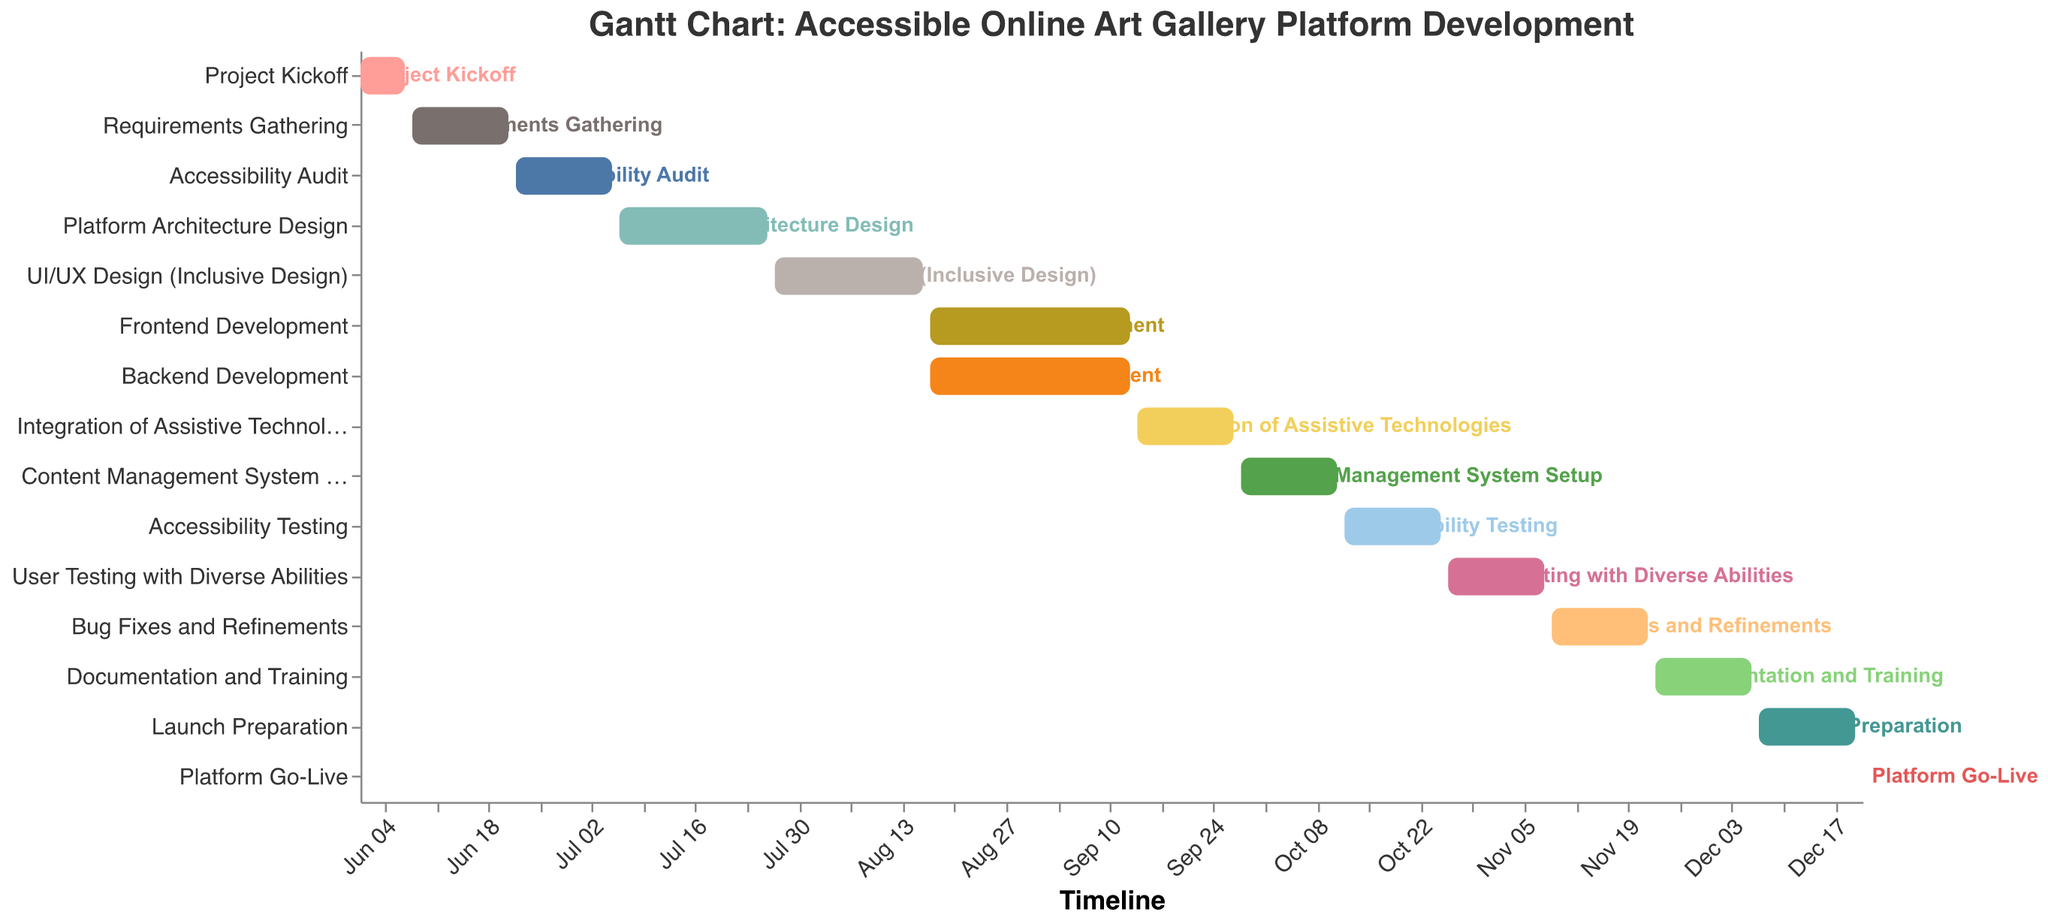What's the duration of the "Frontend Development" task? The duration of the "Frontend Development" task can be found directly in the bar representing this task, which is labeled with its start and end dates. The duration is also specified in the data as 28 days.
Answer: 28 days Which task starts immediately after the "Project Kickoff"? By examining the timeline and the labels on the horizontal axis, it is clear that "Requirements Gathering" starts immediately after the "Project Kickoff".
Answer: Requirements Gathering How many tasks have a duration of 14 days? By scanning the tasks and their durations on the Gantt Chart, we can see that there are seven tasks with a duration of 14 days: "Requirements Gathering", "Accessibility Audit", "Integration of Assistive Technologies", "Content Management System Setup", "Accessibility Testing", "User Testing with Diverse Abilities", "Bug Fixes and Refinements", "Documentation and Training", and "Launch Preparation".
Answer: 8 tasks Which tasks overlap with "Frontend Development"? By checking the time span of "Frontend Development" from August 17 to September 13, we can identify tasks that overlap with these dates: "Backend Development" completely overlaps as it has the same start and end dates.
Answer: Backend Development What is the color scheme used for distinguishing different tasks? The tasks are colored using the "tableau20" color scheme, resulting in distinct colors for each task for visual clarity, as seen in the visual preview.
Answer: tableau20 Which task has the shortest duration and what is it? By looking at the durations of each task, the "Platform Go-Live" has the shortest duration, which is just 1 day.
Answer: Platform Go-Live How many tasks are scheduled to occur in July? The Gantt Chart shows that "Accessibility Audit," "Platform Architecture Design," and "UI/UX Design (Inclusive Design)" are the tasks scheduled in July. Counting these, we have three tasks in July.
Answer: 3 tasks For how many days do "Frontend Development" and "Backend Development" occur simultaneously? Both tasks start on August 17 and end on September 13, meaning they span the same 28 days.
Answer: 28 days How many tasks are planned to be completed before October 1st, 2023? Tasks "Project Kickoff", "Requirements Gathering", "Accessibility Audit", "Platform Architecture Design", "UI/UX Design (Inclusive Design)", "Frontend Development", "Backend Development", "Integration of Assistive Technologies", and "Content Management System Setup" are planned to be completed before October 1st. This counts up to 9 tasks.
Answer: 9 tasks What task involves user testing and how long does it last? The task involving user testing is "User Testing with Diverse Abilities," and it lasts for 14 days.
Answer: User Testing with Diverse Abilities 